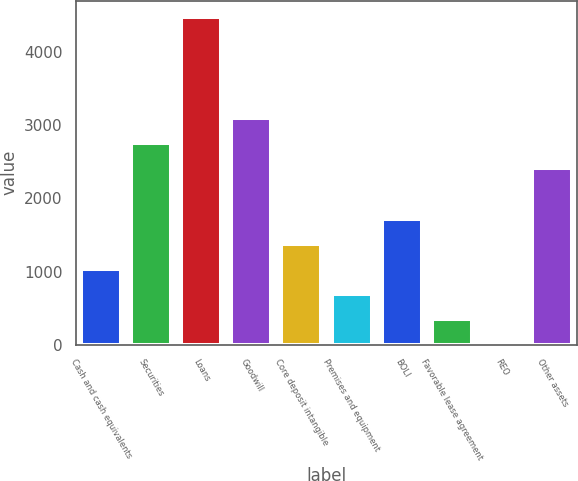Convert chart. <chart><loc_0><loc_0><loc_500><loc_500><bar_chart><fcel>Cash and cash equivalents<fcel>Securities<fcel>Loans<fcel>Goodwill<fcel>Core deposit intangible<fcel>Premises and equipment<fcel>BOLI<fcel>Favorable lease agreement<fcel>REO<fcel>Other assets<nl><fcel>1035.17<fcel>2760.12<fcel>4485.07<fcel>3105.11<fcel>1380.16<fcel>690.18<fcel>1725.15<fcel>345.19<fcel>0.2<fcel>2415.13<nl></chart> 